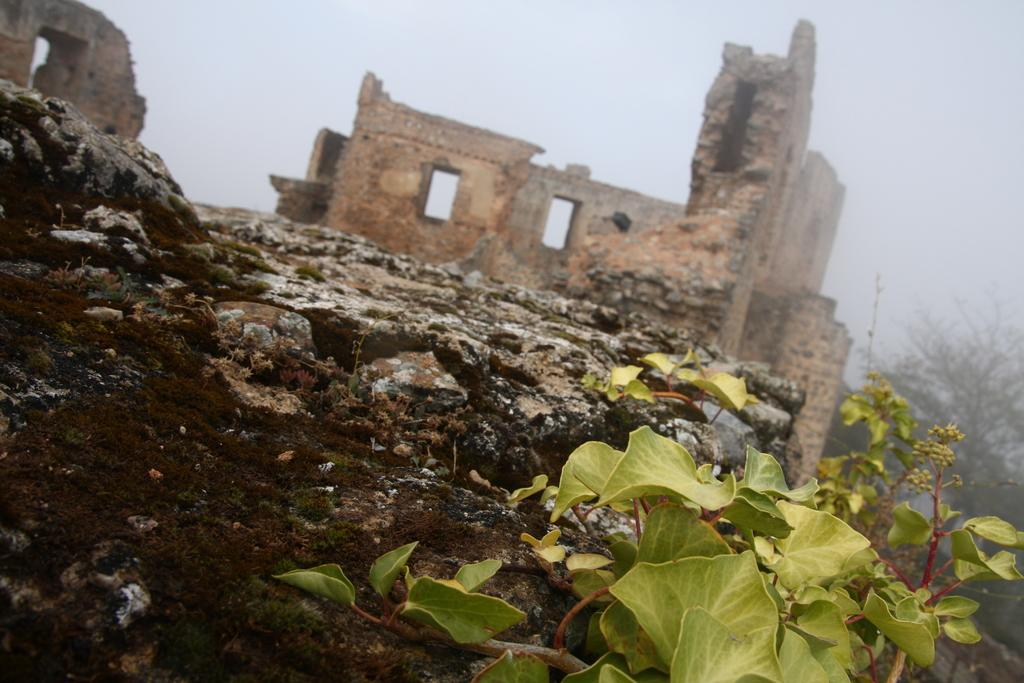What type of natural elements can be seen in the image? There are stones and plants visible in the image. What type of structure can be seen in the background of the image? There is a fort in the background of the image. What other features can be seen in the background of the image? There is a wall, trees, and the sky visible in the background of the image. Can you see any icicles hanging from the trees in the image? There are no icicles present in the image; it appears to be a warm setting with trees and a sky visible in the background. What type of seed is being used to grow the plants in the image? There is no information about seeds in the image; it only shows stones, plants, a fort, a wall, trees, and the sky. 